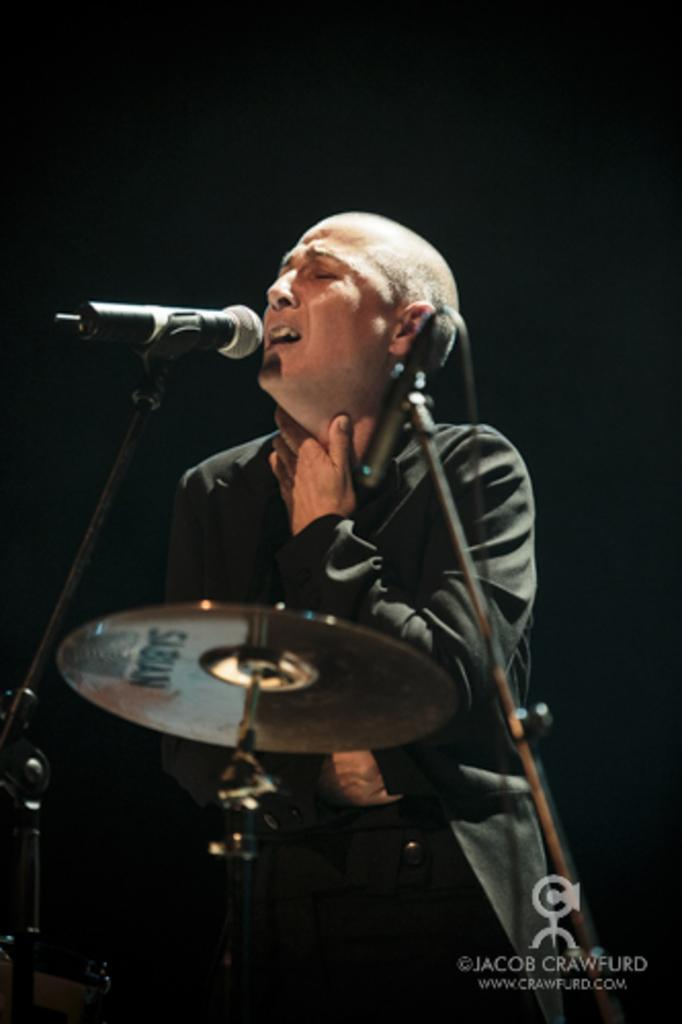What is the person in the image doing? The person in the image is singing. What is the person wearing? The person is wearing a black dress. What objects are in front of the person? There are mice and drums in front of the person. What does the person's brother think about their singing performance? There is no mention of a brother in the image or the provided facts, so it is impossible to answer this question. 